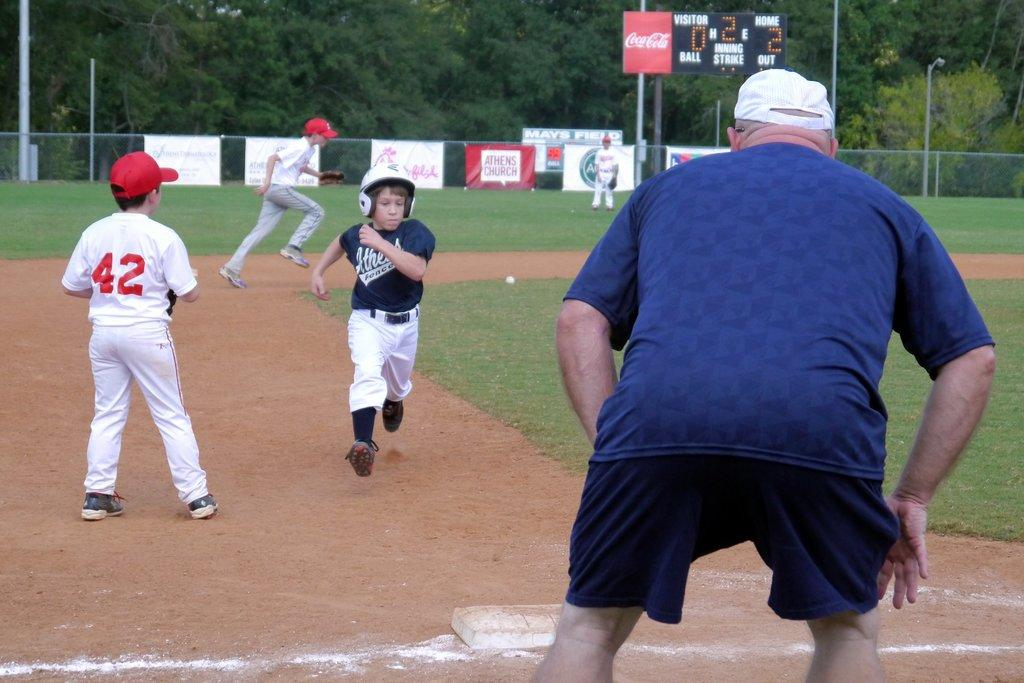<image>
Create a compact narrative representing the image presented. Number 42 waits for the ball as the batter is running towards the base with 2 outs. 